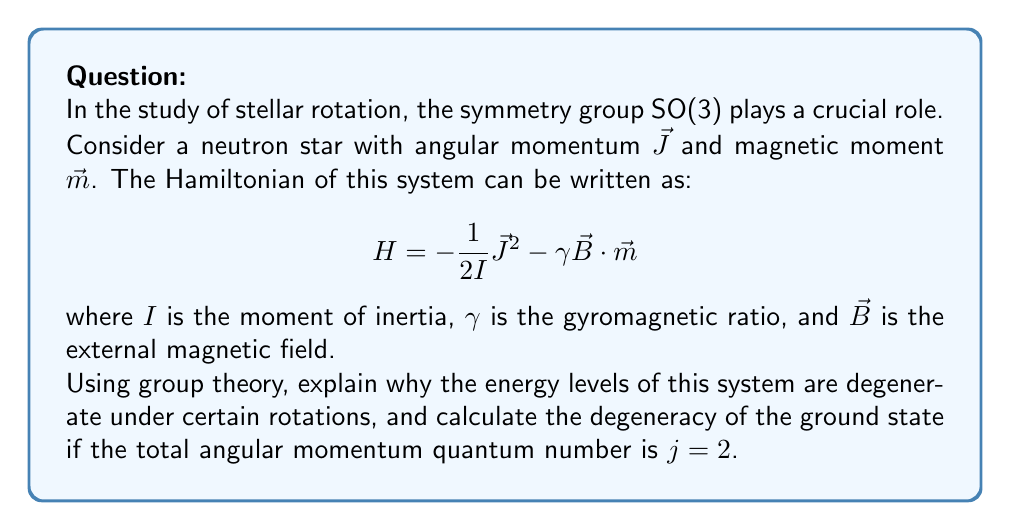What is the answer to this math problem? To address this problem, we'll use the principles of group theory in quantum mechanics:

1) The Hamiltonian $H$ is invariant under rotations that belong to the SO(3) group. This is because both $\mathbf{J}^2$ and $\mathbf{B} \cdot \mathbf{m}$ are scalar quantities, which remain unchanged under rotations.

2) According to Noether's theorem, this rotational symmetry implies the conservation of angular momentum. The eigenstates of $H$ can thus be labeled by the quantum numbers $j$ (total angular momentum) and $m$ (its projection along a chosen axis).

3) For a given $j$, there are $2j+1$ possible values of $m$, ranging from $-j$ to $+j$ in integer steps. These states have the same energy due to the rotational symmetry, leading to degeneracy.

4) The degeneracy is directly related to the dimensionality of the irreducible representations of SO(3) for a given $j$. For the SO(3) group, these irreducible representations have dimension $2j+1$.

5) In our case, we're asked about the ground state with $j=2$. Therefore, the degeneracy is:

   $$\text{Degeneracy} = 2j + 1 = 2(2) + 1 = 5$$

This means there are 5 degenerate states in the ground state, corresponding to $m = -2, -1, 0, 1, 2$.

The group theoretical approach allows us to determine this degeneracy without solving the Schrödinger equation explicitly, demonstrating the power of symmetry considerations in quantum mechanical systems.
Answer: 5 